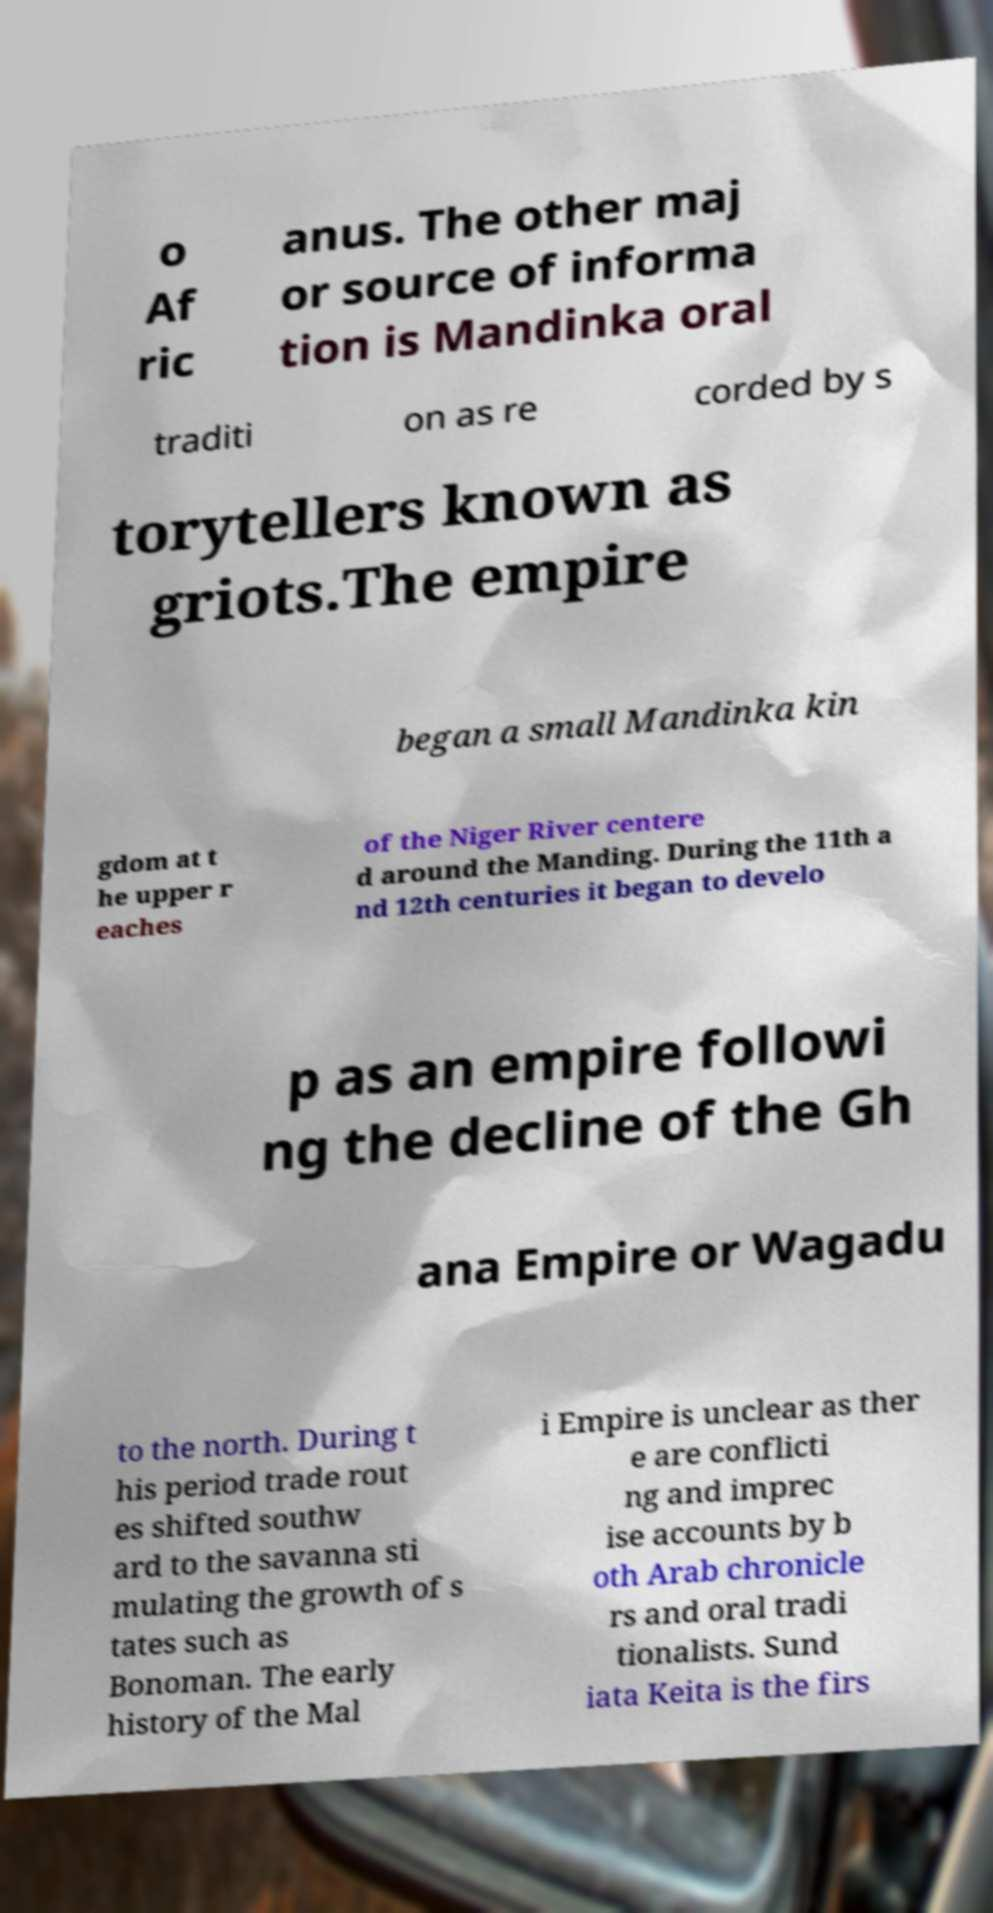Please read and relay the text visible in this image. What does it say? o Af ric anus. The other maj or source of informa tion is Mandinka oral traditi on as re corded by s torytellers known as griots.The empire began a small Mandinka kin gdom at t he upper r eaches of the Niger River centere d around the Manding. During the 11th a nd 12th centuries it began to develo p as an empire followi ng the decline of the Gh ana Empire or Wagadu to the north. During t his period trade rout es shifted southw ard to the savanna sti mulating the growth of s tates such as Bonoman. The early history of the Mal i Empire is unclear as ther e are conflicti ng and imprec ise accounts by b oth Arab chronicle rs and oral tradi tionalists. Sund iata Keita is the firs 